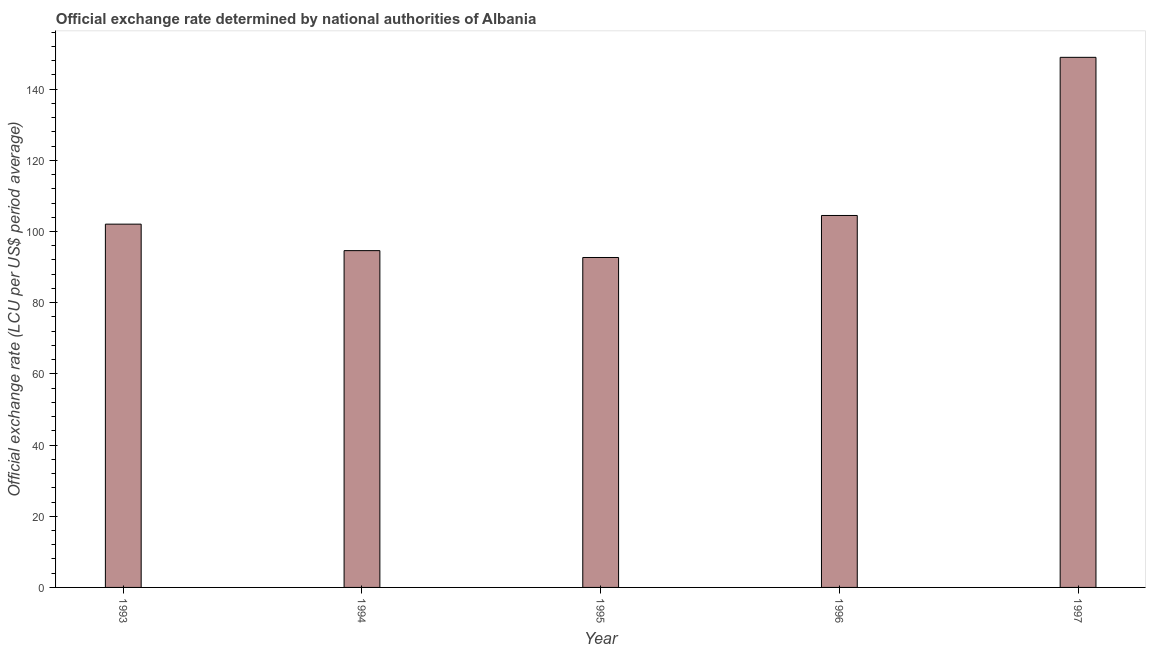Does the graph contain any zero values?
Your answer should be very brief. No. Does the graph contain grids?
Your answer should be compact. No. What is the title of the graph?
Offer a very short reply. Official exchange rate determined by national authorities of Albania. What is the label or title of the Y-axis?
Keep it short and to the point. Official exchange rate (LCU per US$ period average). What is the official exchange rate in 1997?
Ensure brevity in your answer.  148.93. Across all years, what is the maximum official exchange rate?
Make the answer very short. 148.93. Across all years, what is the minimum official exchange rate?
Your response must be concise. 92.7. In which year was the official exchange rate minimum?
Offer a terse response. 1995. What is the sum of the official exchange rate?
Offer a terse response. 542.82. What is the difference between the official exchange rate in 1994 and 1995?
Ensure brevity in your answer.  1.93. What is the average official exchange rate per year?
Make the answer very short. 108.56. What is the median official exchange rate?
Provide a succinct answer. 102.06. In how many years, is the official exchange rate greater than 32 ?
Keep it short and to the point. 5. What is the ratio of the official exchange rate in 1993 to that in 1995?
Provide a succinct answer. 1.1. Is the official exchange rate in 1996 less than that in 1997?
Your response must be concise. Yes. Is the difference between the official exchange rate in 1993 and 1996 greater than the difference between any two years?
Your answer should be very brief. No. What is the difference between the highest and the second highest official exchange rate?
Offer a very short reply. 44.43. Is the sum of the official exchange rate in 1993 and 1996 greater than the maximum official exchange rate across all years?
Your answer should be very brief. Yes. What is the difference between the highest and the lowest official exchange rate?
Your answer should be very brief. 56.24. How many bars are there?
Ensure brevity in your answer.  5. How many years are there in the graph?
Provide a short and direct response. 5. What is the difference between two consecutive major ticks on the Y-axis?
Offer a very short reply. 20. What is the Official exchange rate (LCU per US$ period average) of 1993?
Keep it short and to the point. 102.06. What is the Official exchange rate (LCU per US$ period average) of 1994?
Make the answer very short. 94.62. What is the Official exchange rate (LCU per US$ period average) of 1995?
Your answer should be very brief. 92.7. What is the Official exchange rate (LCU per US$ period average) of 1996?
Provide a succinct answer. 104.5. What is the Official exchange rate (LCU per US$ period average) of 1997?
Make the answer very short. 148.93. What is the difference between the Official exchange rate (LCU per US$ period average) in 1993 and 1994?
Offer a very short reply. 7.44. What is the difference between the Official exchange rate (LCU per US$ period average) in 1993 and 1995?
Ensure brevity in your answer.  9.37. What is the difference between the Official exchange rate (LCU per US$ period average) in 1993 and 1996?
Ensure brevity in your answer.  -2.44. What is the difference between the Official exchange rate (LCU per US$ period average) in 1993 and 1997?
Provide a short and direct response. -46.87. What is the difference between the Official exchange rate (LCU per US$ period average) in 1994 and 1995?
Offer a terse response. 1.93. What is the difference between the Official exchange rate (LCU per US$ period average) in 1994 and 1996?
Your answer should be compact. -9.88. What is the difference between the Official exchange rate (LCU per US$ period average) in 1994 and 1997?
Give a very brief answer. -54.31. What is the difference between the Official exchange rate (LCU per US$ period average) in 1995 and 1996?
Ensure brevity in your answer.  -11.8. What is the difference between the Official exchange rate (LCU per US$ period average) in 1995 and 1997?
Provide a succinct answer. -56.24. What is the difference between the Official exchange rate (LCU per US$ period average) in 1996 and 1997?
Your response must be concise. -44.43. What is the ratio of the Official exchange rate (LCU per US$ period average) in 1993 to that in 1994?
Your answer should be compact. 1.08. What is the ratio of the Official exchange rate (LCU per US$ period average) in 1993 to that in 1995?
Make the answer very short. 1.1. What is the ratio of the Official exchange rate (LCU per US$ period average) in 1993 to that in 1997?
Provide a short and direct response. 0.69. What is the ratio of the Official exchange rate (LCU per US$ period average) in 1994 to that in 1996?
Ensure brevity in your answer.  0.91. What is the ratio of the Official exchange rate (LCU per US$ period average) in 1994 to that in 1997?
Keep it short and to the point. 0.64. What is the ratio of the Official exchange rate (LCU per US$ period average) in 1995 to that in 1996?
Offer a terse response. 0.89. What is the ratio of the Official exchange rate (LCU per US$ period average) in 1995 to that in 1997?
Ensure brevity in your answer.  0.62. What is the ratio of the Official exchange rate (LCU per US$ period average) in 1996 to that in 1997?
Give a very brief answer. 0.7. 